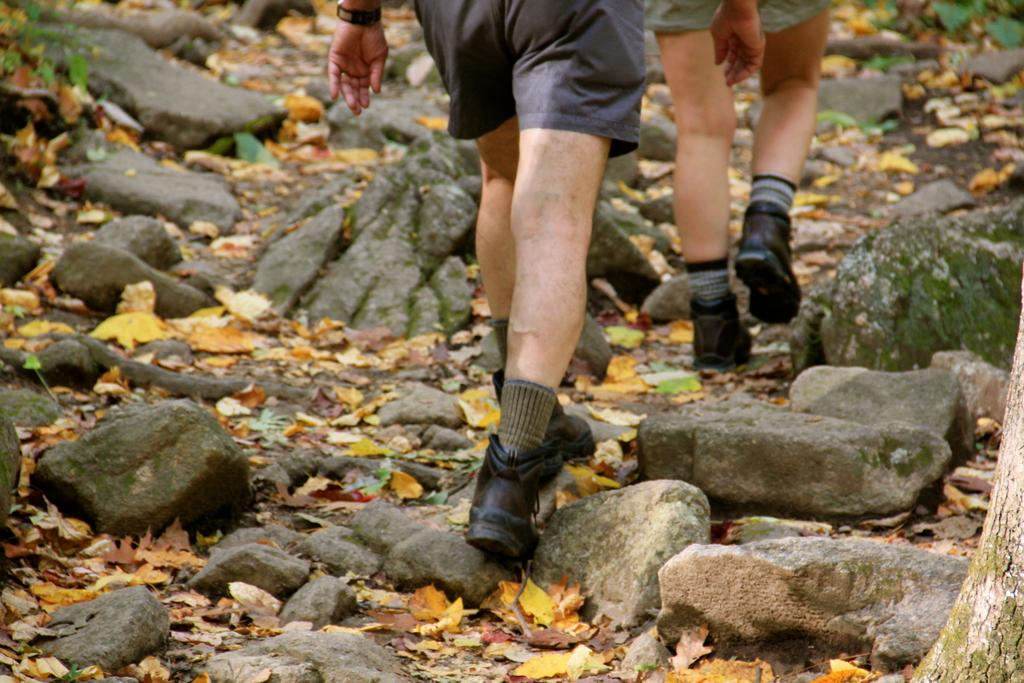How many people are in the image? There are two people in the image. What are the people doing in the image? The people are walking. What type of terrain is visible in the image? There is earth, rocks, and dry leaves in the image. What type of string is being used by the aunt in the image? There is no aunt present in the image, and therefore no string being used. 